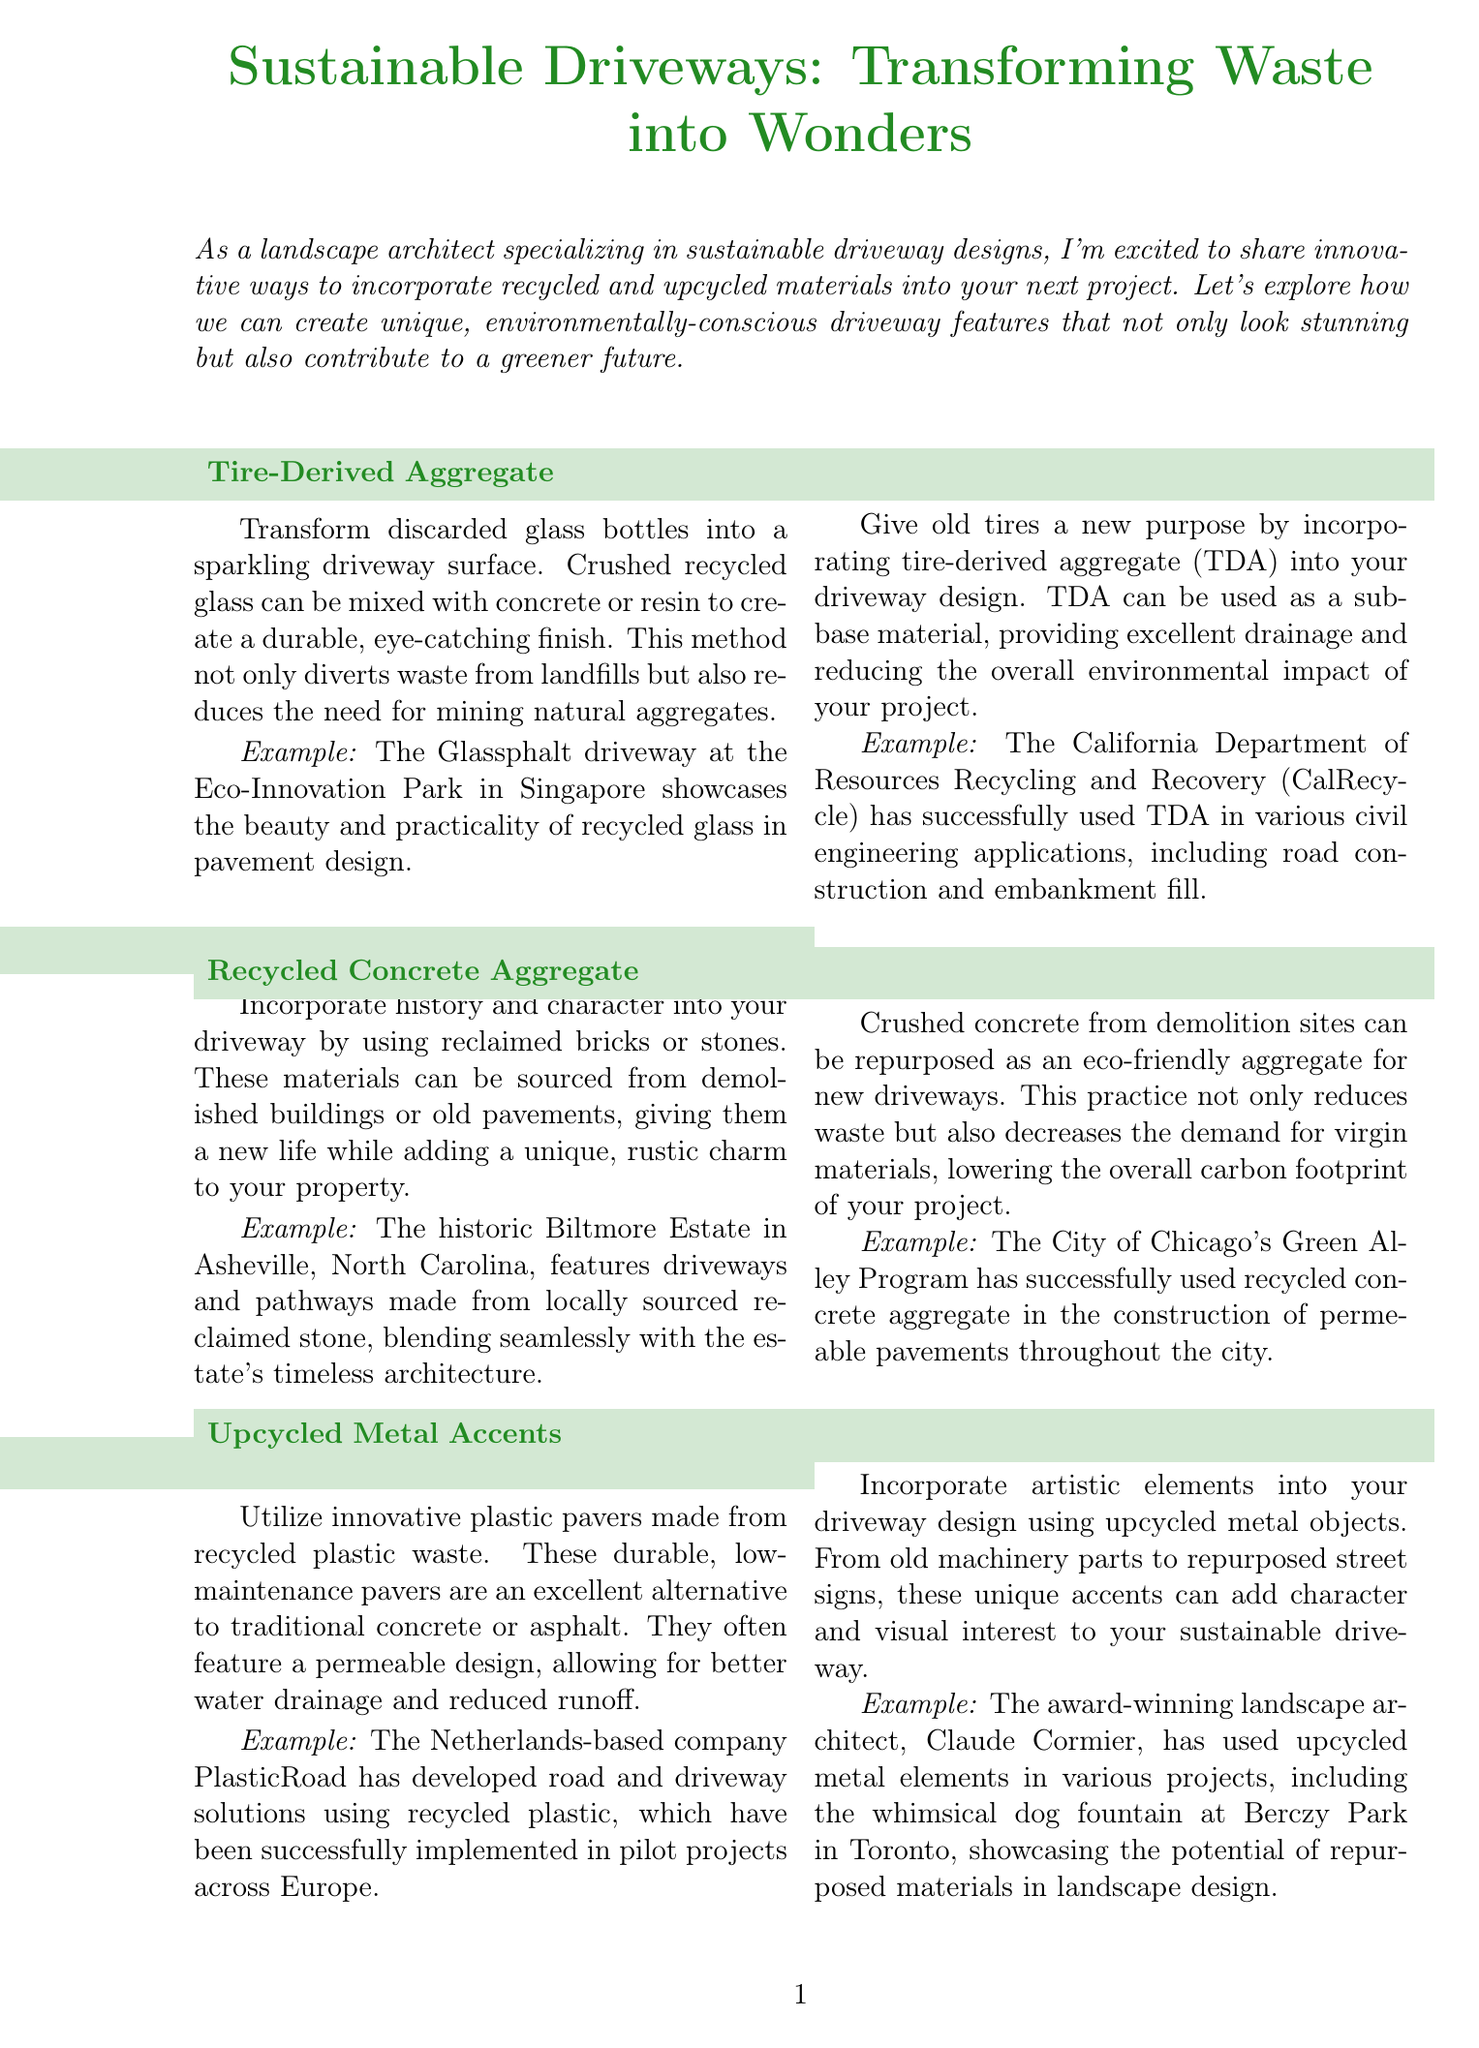What is the title of the newsletter? The title of the newsletter is mentioned at the beginning of the document.
Answer: Sustainable Driveways: Transforming Waste into Wonders What material is used in the Glassphalt driveway? The content mentions that crushed recycled glass can be mixed with concrete or resin.
Answer: Crushed recycled glass Where is the historic Biltmore Estate located? The document specifies the location of the Biltmore Estate within the section about reclaimed brick and stone.
Answer: Asheville, North Carolina What is the main benefit of using recycled plastic pavers? The document states that these pavers are an excellent alternative to traditional materials and often feature a permeable design.
Answer: Better water drainage What does TDA stand for in the context of driveway design? The acronym is defined in the section about tire-derived aggregate.
Answer: Tire-Derived Aggregate Which company developed road solutions using recycled plastic? This information is provided in the section about recycled plastic pavers.
Answer: PlasticRoad What is a common aesthetic use for upcycled metal objects in driveways? The document mentions incorporating artistic elements as a way to utilize upcycled metal.
Answer: Artistic elements In which project did Claude Cormier use upcycled metal elements? The document gives a specific example of a project to illustrate this use.
Answer: Berczy Park in Toronto What is the overall theme of the newsletter? The introduction outlines the primary focus of the newsletter.
Answer: Sustainability and recycled materials 